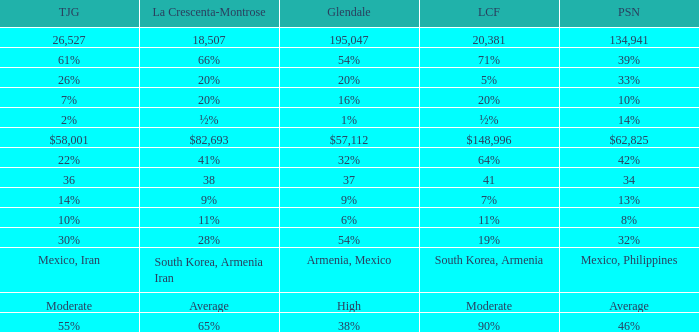What is the fraction of tujunja when pasadena represents 33%? 26%. 